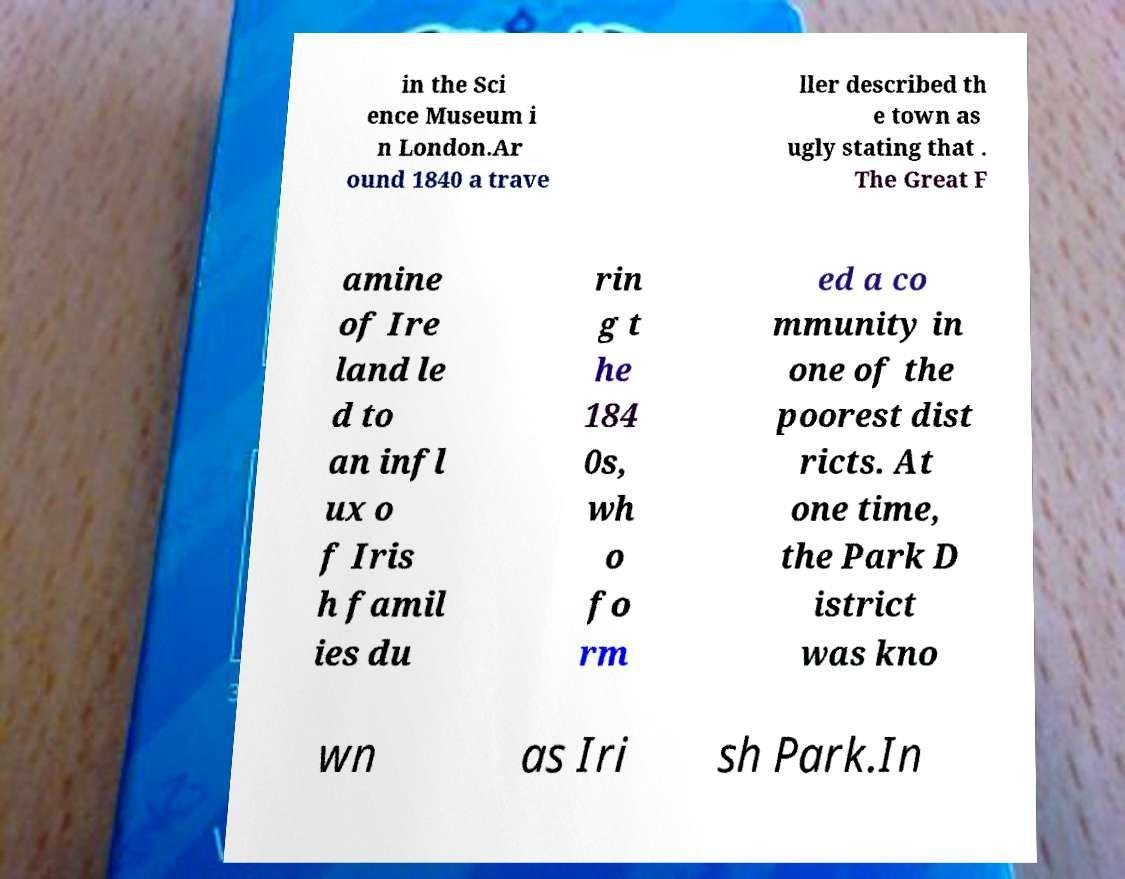Please identify and transcribe the text found in this image. in the Sci ence Museum i n London.Ar ound 1840 a trave ller described th e town as ugly stating that . The Great F amine of Ire land le d to an infl ux o f Iris h famil ies du rin g t he 184 0s, wh o fo rm ed a co mmunity in one of the poorest dist ricts. At one time, the Park D istrict was kno wn as Iri sh Park.In 